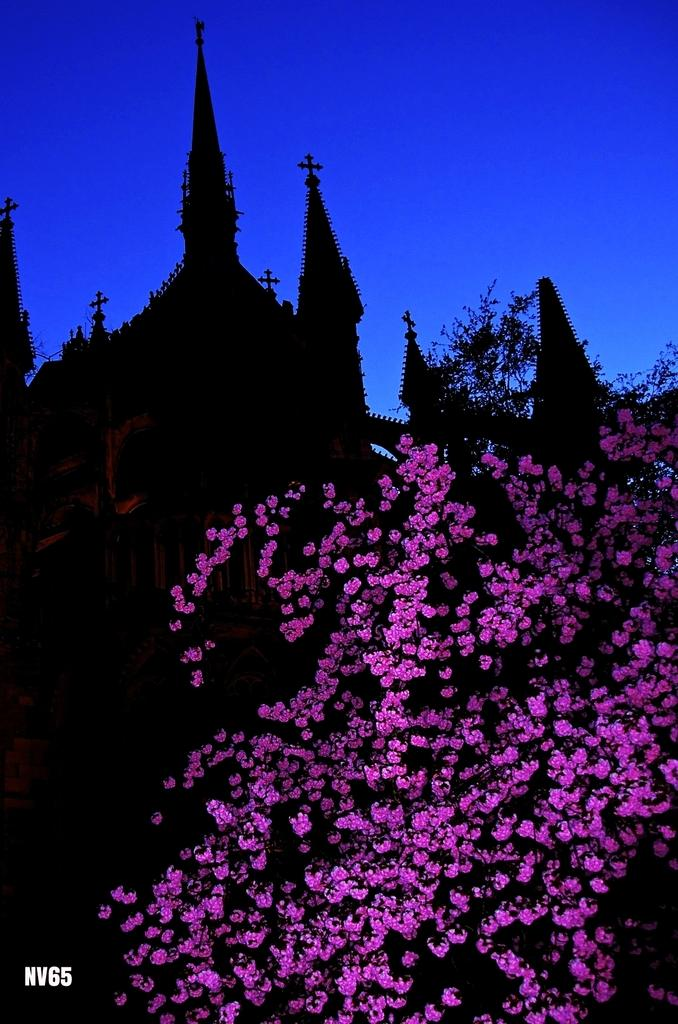What type of plants are on the right side of the image? There are plants with pink flowers on the right side of the image. What can be found on the bottom left of the image? There is a watermark on the bottom left of the image. What is visible in the background of the image? There are buildings and a blue sky in the background of the image. What type of yam is being used to reduce friction in the image? There is no yam or mention of friction in the image. What language is being spoken by the plants in the image? The image does not depict any plants speaking a language. 